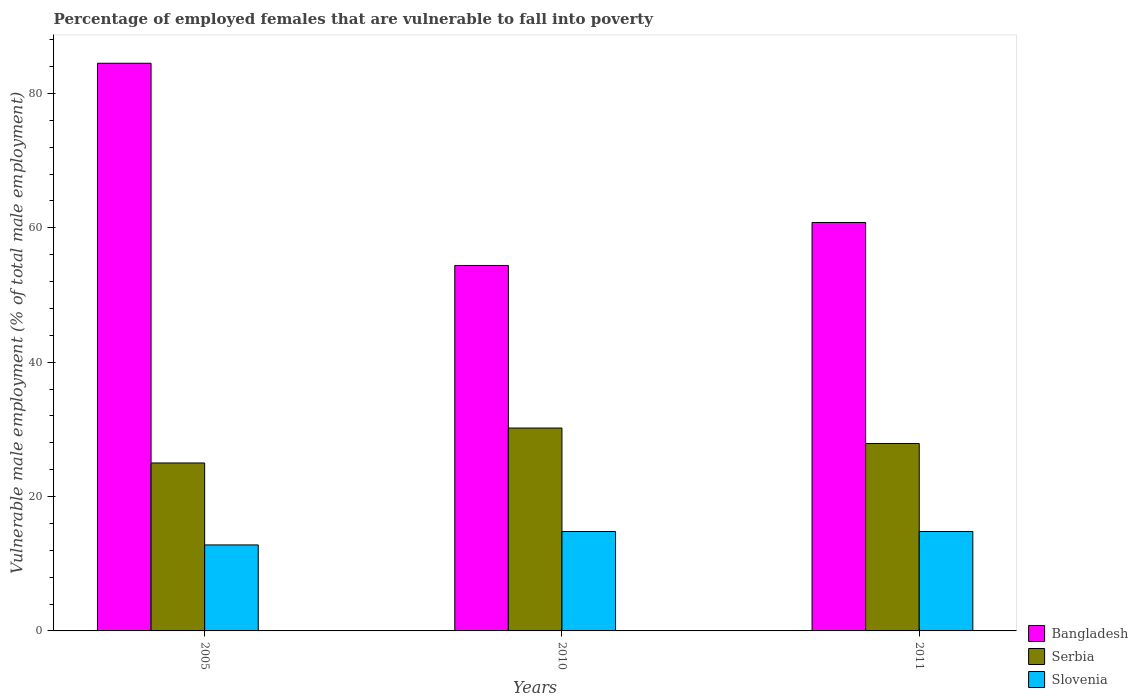How many different coloured bars are there?
Your answer should be compact. 3. Are the number of bars on each tick of the X-axis equal?
Offer a terse response. Yes. How many bars are there on the 3rd tick from the right?
Your answer should be very brief. 3. What is the percentage of employed females who are vulnerable to fall into poverty in Slovenia in 2005?
Your answer should be very brief. 12.8. Across all years, what is the maximum percentage of employed females who are vulnerable to fall into poverty in Bangladesh?
Your answer should be very brief. 84.5. Across all years, what is the minimum percentage of employed females who are vulnerable to fall into poverty in Slovenia?
Your answer should be very brief. 12.8. In which year was the percentage of employed females who are vulnerable to fall into poverty in Slovenia maximum?
Give a very brief answer. 2010. What is the total percentage of employed females who are vulnerable to fall into poverty in Bangladesh in the graph?
Offer a terse response. 199.7. What is the difference between the percentage of employed females who are vulnerable to fall into poverty in Serbia in 2010 and that in 2011?
Offer a very short reply. 2.3. What is the difference between the percentage of employed females who are vulnerable to fall into poverty in Slovenia in 2010 and the percentage of employed females who are vulnerable to fall into poverty in Serbia in 2005?
Provide a short and direct response. -10.2. What is the average percentage of employed females who are vulnerable to fall into poverty in Serbia per year?
Your answer should be compact. 27.7. In the year 2005, what is the difference between the percentage of employed females who are vulnerable to fall into poverty in Slovenia and percentage of employed females who are vulnerable to fall into poverty in Serbia?
Your answer should be very brief. -12.2. What is the ratio of the percentage of employed females who are vulnerable to fall into poverty in Serbia in 2010 to that in 2011?
Keep it short and to the point. 1.08. What is the difference between the highest and the second highest percentage of employed females who are vulnerable to fall into poverty in Bangladesh?
Offer a terse response. 23.7. What is the difference between the highest and the lowest percentage of employed females who are vulnerable to fall into poverty in Slovenia?
Your answer should be very brief. 2. What does the 1st bar from the left in 2010 represents?
Offer a terse response. Bangladesh. What does the 1st bar from the right in 2010 represents?
Your answer should be compact. Slovenia. Is it the case that in every year, the sum of the percentage of employed females who are vulnerable to fall into poverty in Slovenia and percentage of employed females who are vulnerable to fall into poverty in Serbia is greater than the percentage of employed females who are vulnerable to fall into poverty in Bangladesh?
Keep it short and to the point. No. How many bars are there?
Provide a succinct answer. 9. How many years are there in the graph?
Ensure brevity in your answer.  3. Are the values on the major ticks of Y-axis written in scientific E-notation?
Ensure brevity in your answer.  No. Does the graph contain grids?
Ensure brevity in your answer.  No. Where does the legend appear in the graph?
Your answer should be very brief. Bottom right. What is the title of the graph?
Keep it short and to the point. Percentage of employed females that are vulnerable to fall into poverty. Does "Saudi Arabia" appear as one of the legend labels in the graph?
Keep it short and to the point. No. What is the label or title of the Y-axis?
Your answer should be very brief. Vulnerable male employment (% of total male employment). What is the Vulnerable male employment (% of total male employment) of Bangladesh in 2005?
Provide a succinct answer. 84.5. What is the Vulnerable male employment (% of total male employment) in Slovenia in 2005?
Provide a succinct answer. 12.8. What is the Vulnerable male employment (% of total male employment) of Bangladesh in 2010?
Offer a very short reply. 54.4. What is the Vulnerable male employment (% of total male employment) of Serbia in 2010?
Make the answer very short. 30.2. What is the Vulnerable male employment (% of total male employment) in Slovenia in 2010?
Make the answer very short. 14.8. What is the Vulnerable male employment (% of total male employment) in Bangladesh in 2011?
Your answer should be compact. 60.8. What is the Vulnerable male employment (% of total male employment) of Serbia in 2011?
Make the answer very short. 27.9. What is the Vulnerable male employment (% of total male employment) of Slovenia in 2011?
Offer a very short reply. 14.8. Across all years, what is the maximum Vulnerable male employment (% of total male employment) of Bangladesh?
Your response must be concise. 84.5. Across all years, what is the maximum Vulnerable male employment (% of total male employment) of Serbia?
Offer a very short reply. 30.2. Across all years, what is the maximum Vulnerable male employment (% of total male employment) of Slovenia?
Offer a terse response. 14.8. Across all years, what is the minimum Vulnerable male employment (% of total male employment) of Bangladesh?
Provide a succinct answer. 54.4. Across all years, what is the minimum Vulnerable male employment (% of total male employment) in Serbia?
Make the answer very short. 25. Across all years, what is the minimum Vulnerable male employment (% of total male employment) in Slovenia?
Make the answer very short. 12.8. What is the total Vulnerable male employment (% of total male employment) of Bangladesh in the graph?
Give a very brief answer. 199.7. What is the total Vulnerable male employment (% of total male employment) of Serbia in the graph?
Offer a terse response. 83.1. What is the total Vulnerable male employment (% of total male employment) of Slovenia in the graph?
Provide a succinct answer. 42.4. What is the difference between the Vulnerable male employment (% of total male employment) of Bangladesh in 2005 and that in 2010?
Make the answer very short. 30.1. What is the difference between the Vulnerable male employment (% of total male employment) of Serbia in 2005 and that in 2010?
Your answer should be compact. -5.2. What is the difference between the Vulnerable male employment (% of total male employment) in Slovenia in 2005 and that in 2010?
Your response must be concise. -2. What is the difference between the Vulnerable male employment (% of total male employment) in Bangladesh in 2005 and that in 2011?
Give a very brief answer. 23.7. What is the difference between the Vulnerable male employment (% of total male employment) of Bangladesh in 2005 and the Vulnerable male employment (% of total male employment) of Serbia in 2010?
Provide a succinct answer. 54.3. What is the difference between the Vulnerable male employment (% of total male employment) in Bangladesh in 2005 and the Vulnerable male employment (% of total male employment) in Slovenia in 2010?
Provide a succinct answer. 69.7. What is the difference between the Vulnerable male employment (% of total male employment) in Serbia in 2005 and the Vulnerable male employment (% of total male employment) in Slovenia in 2010?
Provide a short and direct response. 10.2. What is the difference between the Vulnerable male employment (% of total male employment) in Bangladesh in 2005 and the Vulnerable male employment (% of total male employment) in Serbia in 2011?
Your answer should be compact. 56.6. What is the difference between the Vulnerable male employment (% of total male employment) in Bangladesh in 2005 and the Vulnerable male employment (% of total male employment) in Slovenia in 2011?
Give a very brief answer. 69.7. What is the difference between the Vulnerable male employment (% of total male employment) in Serbia in 2005 and the Vulnerable male employment (% of total male employment) in Slovenia in 2011?
Your answer should be compact. 10.2. What is the difference between the Vulnerable male employment (% of total male employment) in Bangladesh in 2010 and the Vulnerable male employment (% of total male employment) in Slovenia in 2011?
Ensure brevity in your answer.  39.6. What is the average Vulnerable male employment (% of total male employment) of Bangladesh per year?
Provide a short and direct response. 66.57. What is the average Vulnerable male employment (% of total male employment) in Serbia per year?
Your response must be concise. 27.7. What is the average Vulnerable male employment (% of total male employment) in Slovenia per year?
Provide a succinct answer. 14.13. In the year 2005, what is the difference between the Vulnerable male employment (% of total male employment) in Bangladesh and Vulnerable male employment (% of total male employment) in Serbia?
Give a very brief answer. 59.5. In the year 2005, what is the difference between the Vulnerable male employment (% of total male employment) of Bangladesh and Vulnerable male employment (% of total male employment) of Slovenia?
Your answer should be compact. 71.7. In the year 2005, what is the difference between the Vulnerable male employment (% of total male employment) of Serbia and Vulnerable male employment (% of total male employment) of Slovenia?
Your answer should be compact. 12.2. In the year 2010, what is the difference between the Vulnerable male employment (% of total male employment) of Bangladesh and Vulnerable male employment (% of total male employment) of Serbia?
Keep it short and to the point. 24.2. In the year 2010, what is the difference between the Vulnerable male employment (% of total male employment) of Bangladesh and Vulnerable male employment (% of total male employment) of Slovenia?
Your answer should be compact. 39.6. In the year 2011, what is the difference between the Vulnerable male employment (% of total male employment) of Bangladesh and Vulnerable male employment (% of total male employment) of Serbia?
Make the answer very short. 32.9. What is the ratio of the Vulnerable male employment (% of total male employment) in Bangladesh in 2005 to that in 2010?
Ensure brevity in your answer.  1.55. What is the ratio of the Vulnerable male employment (% of total male employment) in Serbia in 2005 to that in 2010?
Offer a very short reply. 0.83. What is the ratio of the Vulnerable male employment (% of total male employment) in Slovenia in 2005 to that in 2010?
Offer a terse response. 0.86. What is the ratio of the Vulnerable male employment (% of total male employment) in Bangladesh in 2005 to that in 2011?
Your answer should be very brief. 1.39. What is the ratio of the Vulnerable male employment (% of total male employment) of Serbia in 2005 to that in 2011?
Ensure brevity in your answer.  0.9. What is the ratio of the Vulnerable male employment (% of total male employment) in Slovenia in 2005 to that in 2011?
Your answer should be compact. 0.86. What is the ratio of the Vulnerable male employment (% of total male employment) in Bangladesh in 2010 to that in 2011?
Make the answer very short. 0.89. What is the ratio of the Vulnerable male employment (% of total male employment) in Serbia in 2010 to that in 2011?
Your response must be concise. 1.08. What is the ratio of the Vulnerable male employment (% of total male employment) of Slovenia in 2010 to that in 2011?
Offer a terse response. 1. What is the difference between the highest and the second highest Vulnerable male employment (% of total male employment) in Bangladesh?
Ensure brevity in your answer.  23.7. What is the difference between the highest and the second highest Vulnerable male employment (% of total male employment) in Serbia?
Your response must be concise. 2.3. What is the difference between the highest and the second highest Vulnerable male employment (% of total male employment) in Slovenia?
Your response must be concise. 0. What is the difference between the highest and the lowest Vulnerable male employment (% of total male employment) in Bangladesh?
Keep it short and to the point. 30.1. What is the difference between the highest and the lowest Vulnerable male employment (% of total male employment) of Serbia?
Your answer should be compact. 5.2. 